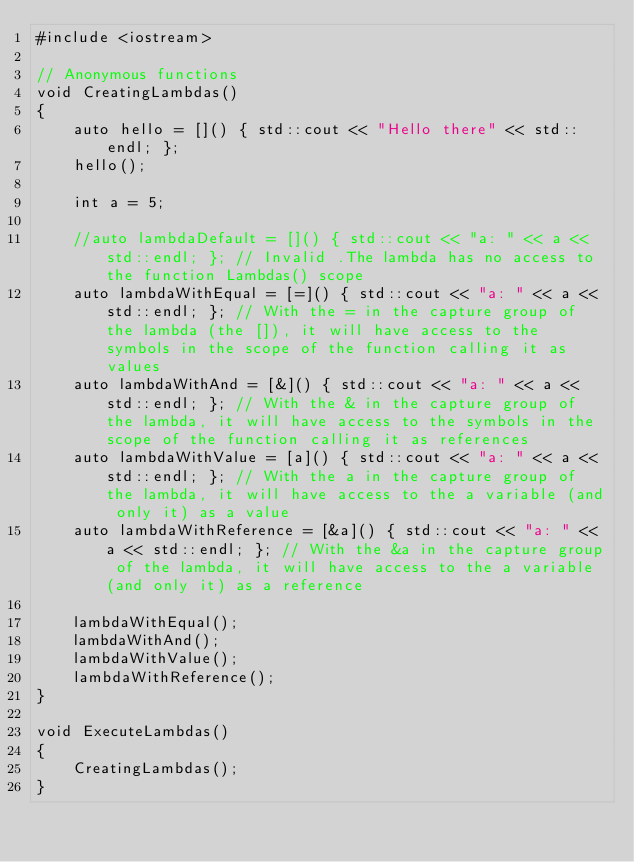Convert code to text. <code><loc_0><loc_0><loc_500><loc_500><_C++_>#include <iostream>

// Anonymous functions
void CreatingLambdas()
{
    auto hello = []() { std::cout << "Hello there" << std::endl; };
    hello();

    int a = 5;

    //auto lambdaDefault = []() { std::cout << "a: " << a << std::endl; }; // Invalid .The lambda has no access to the function Lambdas() scope
    auto lambdaWithEqual = [=]() { std::cout << "a: " << a << std::endl; }; // With the = in the capture group of the lambda (the []), it will have access to the symbols in the scope of the function calling it as values
    auto lambdaWithAnd = [&]() { std::cout << "a: " << a << std::endl; }; // With the & in the capture group of the lambda, it will have access to the symbols in the scope of the function calling it as references
    auto lambdaWithValue = [a]() { std::cout << "a: " << a << std::endl; }; // With the a in the capture group of the lambda, it will have access to the a variable (and only it) as a value
    auto lambdaWithReference = [&a]() { std::cout << "a: " << a << std::endl; }; // With the &a in the capture group of the lambda, it will have access to the a variable (and only it) as a reference

    lambdaWithEqual();
    lambdaWithAnd();
    lambdaWithValue();
    lambdaWithReference();
}

void ExecuteLambdas()
{
    CreatingLambdas();
}
</code> 